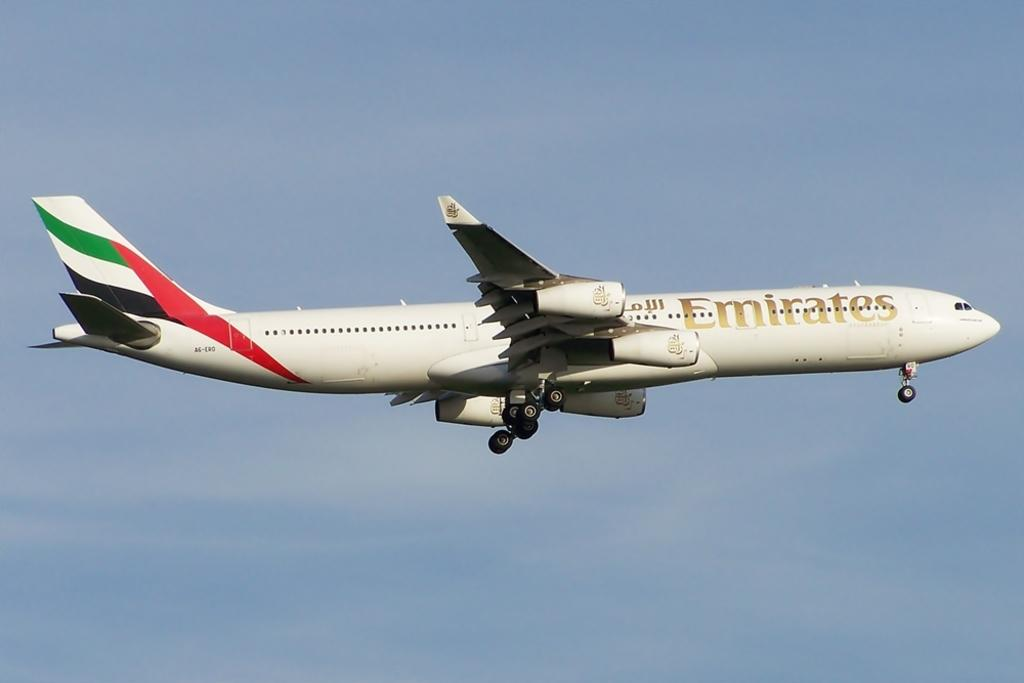<image>
Create a compact narrative representing the image presented. An Emirates plane is flying through a blue sky. 